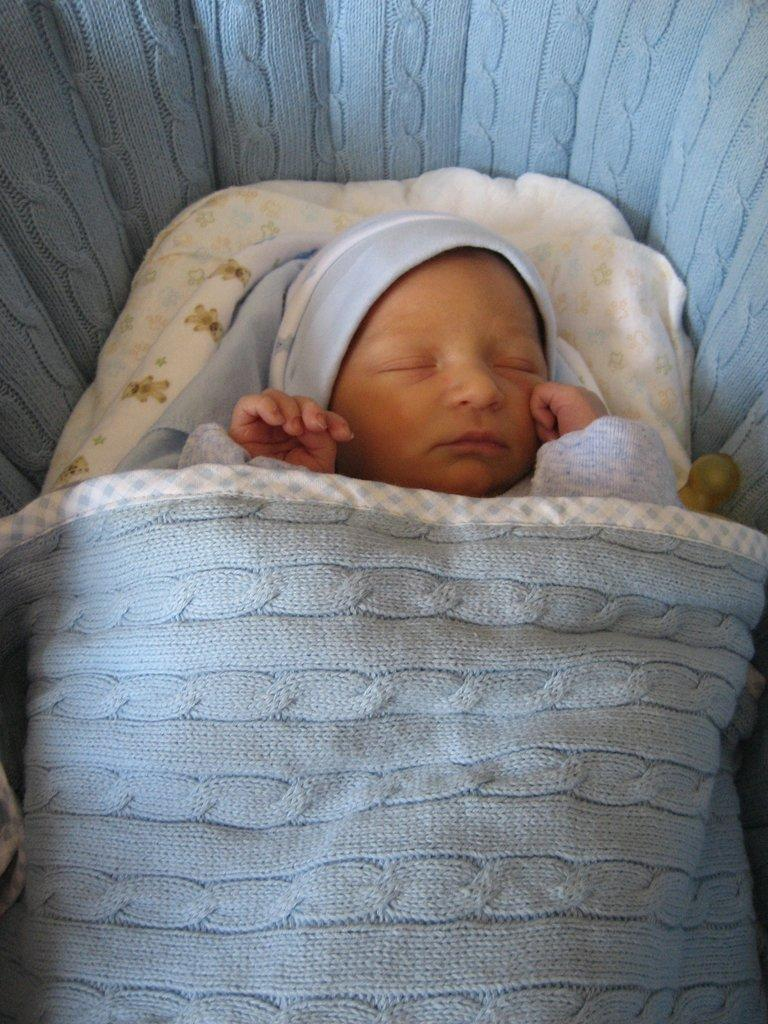What is the main subject of the image? The main subject of the image is a baby. What is the baby doing in the image? The baby is sleeping. Where is the baby positioned in the image? The baby is located in the center of the image. What type of rose is the baby holding in the image? There is no rose present in the image; the baby is sleeping and not holding any object. What type of butter is visible on the baby's patch in the image? There is no butter or patch present in the image; the baby is simply sleeping. 